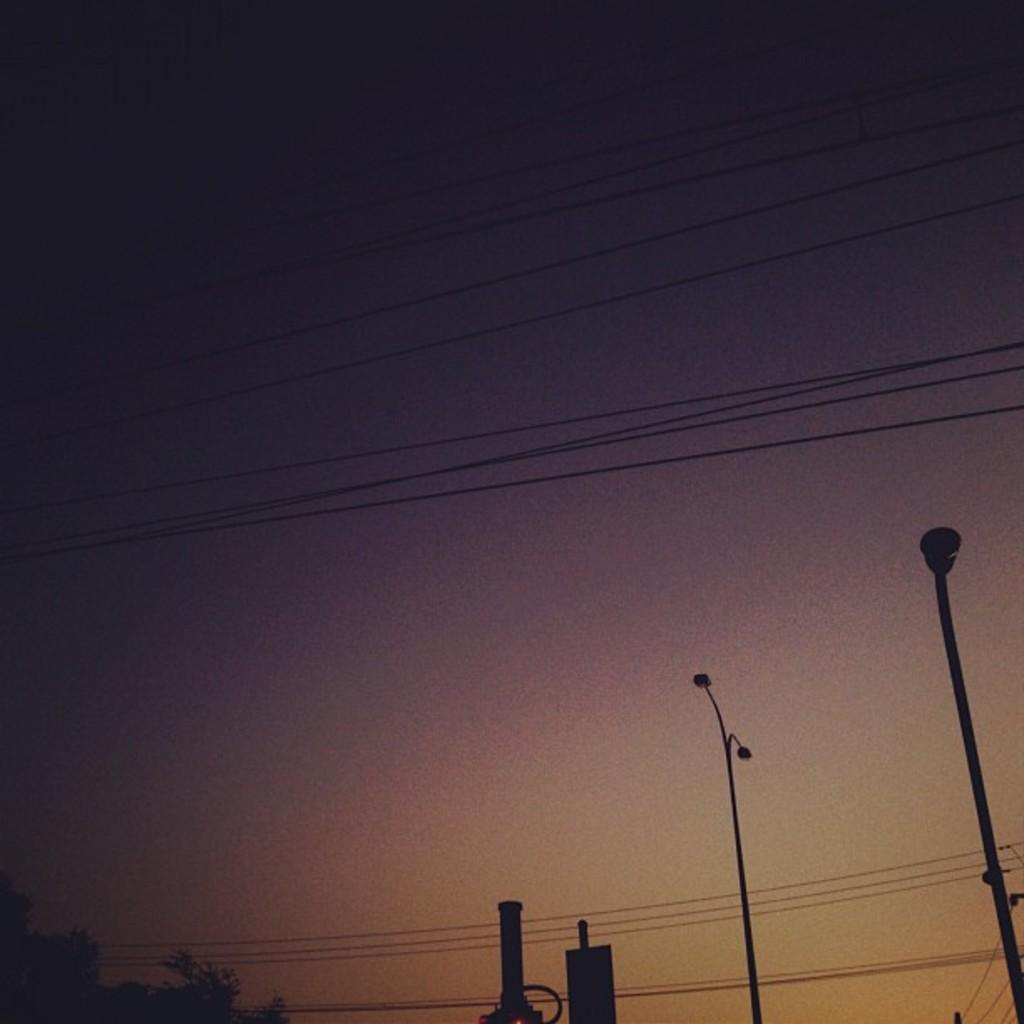What can be seen in the foreground of the image? There are poles in the foreground of the image. What is attached to the poles? There are wires on the poles. Where is the tree located in the image? The tree is in the bottom left of the left of the image. What is visible at the top of the image? The sky is visible at the top of the image, and there are wires visible as well. Can you tell me how many elbows are visible in the image? There are no elbows present in the image. What type of weather condition is depicted in the image? The provided facts do not mention any weather conditions, so we cannot determine if fog or any other weather condition is present in the image. 